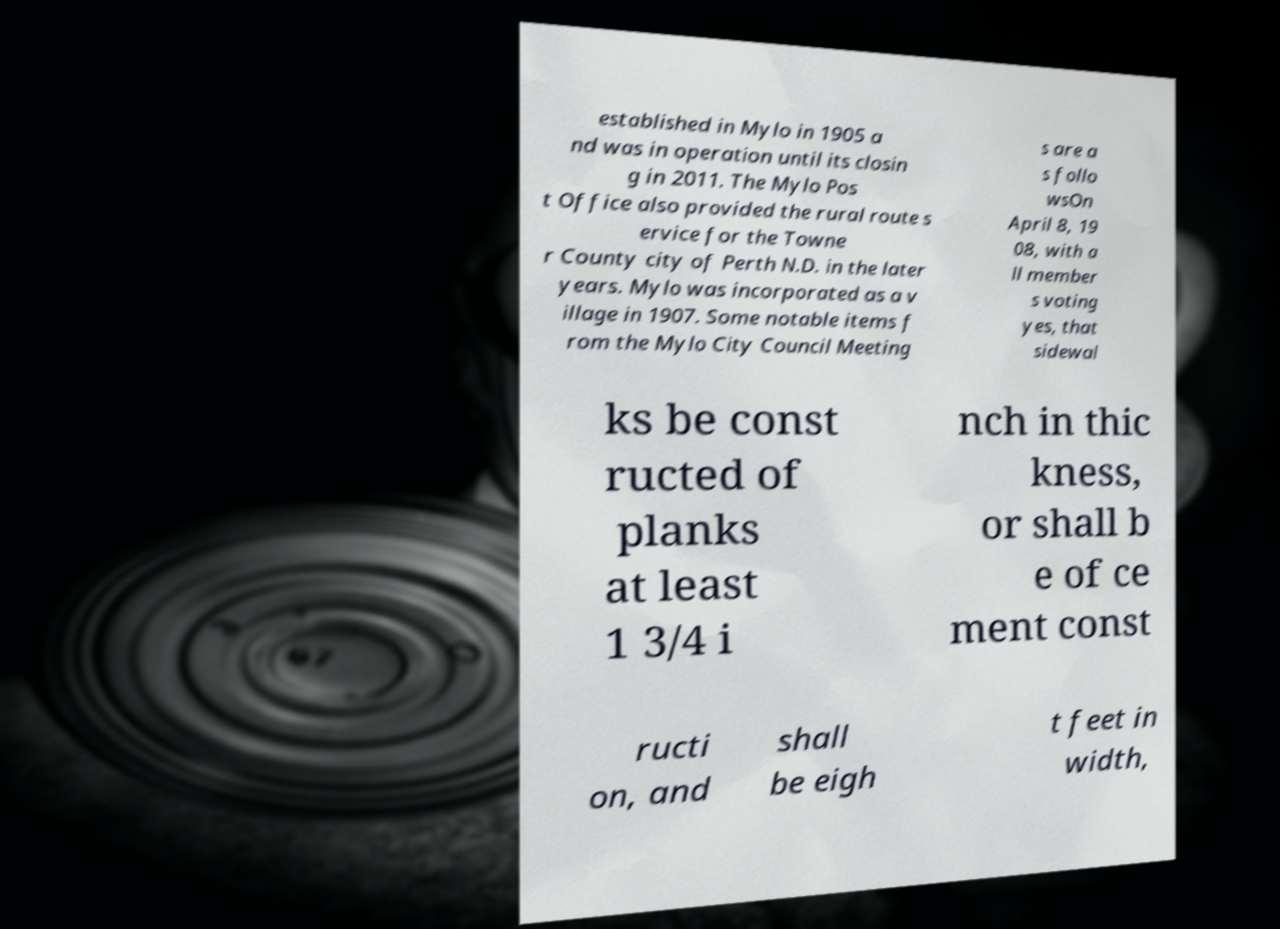Please read and relay the text visible in this image. What does it say? established in Mylo in 1905 a nd was in operation until its closin g in 2011. The Mylo Pos t Office also provided the rural route s ervice for the Towne r County city of Perth N.D. in the later years. Mylo was incorporated as a v illage in 1907. Some notable items f rom the Mylo City Council Meeting s are a s follo wsOn April 8, 19 08, with a ll member s voting yes, that sidewal ks be const ructed of planks at least 1 3/4 i nch in thic kness, or shall b e of ce ment const ructi on, and shall be eigh t feet in width, 